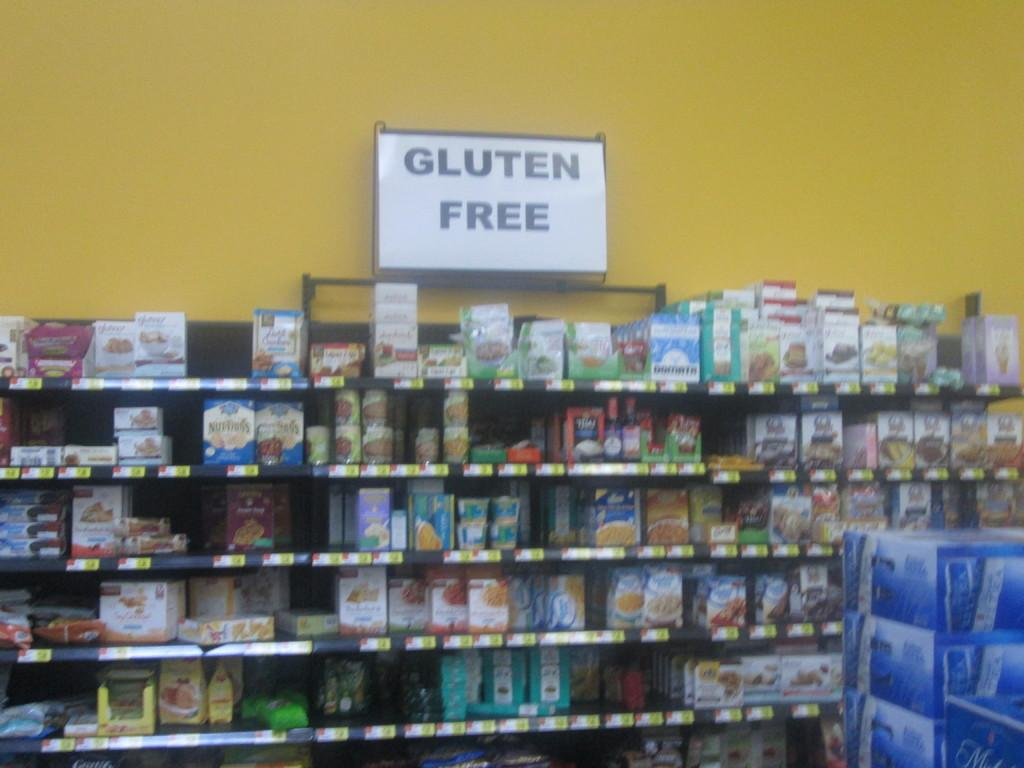<image>
Describe the image concisely. the store has a lot of gluten free options 